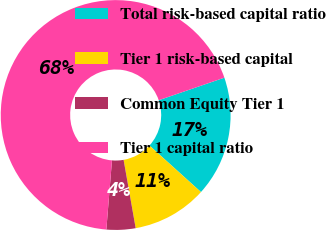Convert chart. <chart><loc_0><loc_0><loc_500><loc_500><pie_chart><fcel>Total risk-based capital ratio<fcel>Tier 1 risk-based capital<fcel>Common Equity Tier 1<fcel>Tier 1 capital ratio<nl><fcel>16.96%<fcel>10.52%<fcel>4.08%<fcel>68.44%<nl></chart> 